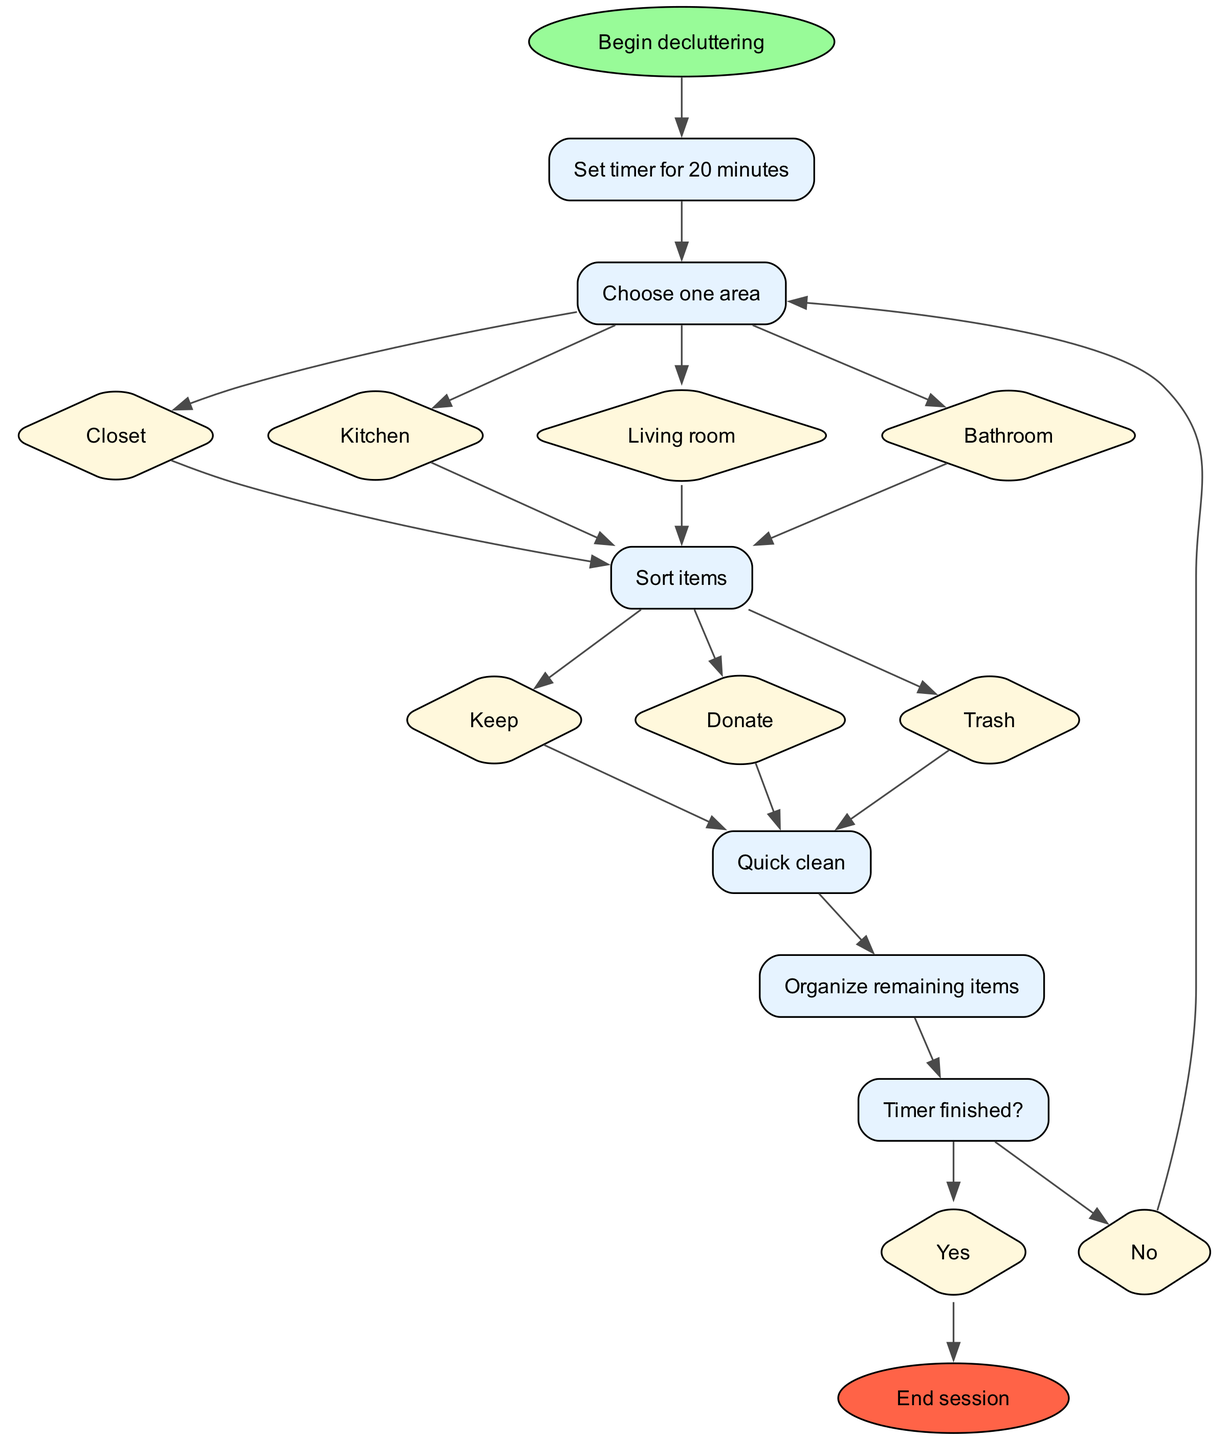What's the first step in the diagram? The first step in the diagram is "Set timer for 20 minutes," which is represented immediately after the start node.
Answer: Set timer for 20 minutes How many areas can you choose to declutter? There are four areas listed: Closet, Kitchen, Living room, and Bathroom. By counting the options in the "Choose one area" step, we find there are four choices available.
Answer: Four What are the options for sorting items? The options for sorting items are "Keep," "Donate," and "Trash," which are found in the "Sort items" step.
Answer: Keep, Donate, Trash If the timer is not finished, which step will you return to? If the timer is not finished, you will return to the "Choose one area" step, as indicated in the decision node after "Timer finished?"
Answer: Choose one area What color is the end node labeled? The end node labeled "End session" is filled with a color representing red, specifically '#FF6347', as it's shown in the diagram with this color scheme for end nodes.
Answer: Red What follows after completing the "Quick clean" step? After completing the "Quick clean" step, the next step is "Organize remaining items," as indicated by the direct flow from "Quick clean" to "Organize remaining items."
Answer: Organize remaining items If you choose the Kitchen area, what is the next action you will take? If you choose the Kitchen area, the next action will be to "Sort items," as it directly follows the choice of one area in the flow of the diagram.
Answer: Sort items What is the last action you can take before the session ends? The last action you can take before ending the session is to "Organize remaining items," which is the step right before the final decision of whether the timer has finished or not.
Answer: Organize remaining items How many options are provided for the "Timer finished?" decision? The "Timer finished?" decision provides two options: "Yes" and "No," indicating whether the timer has finished or not, based on the flow chart's structure.
Answer: Two 